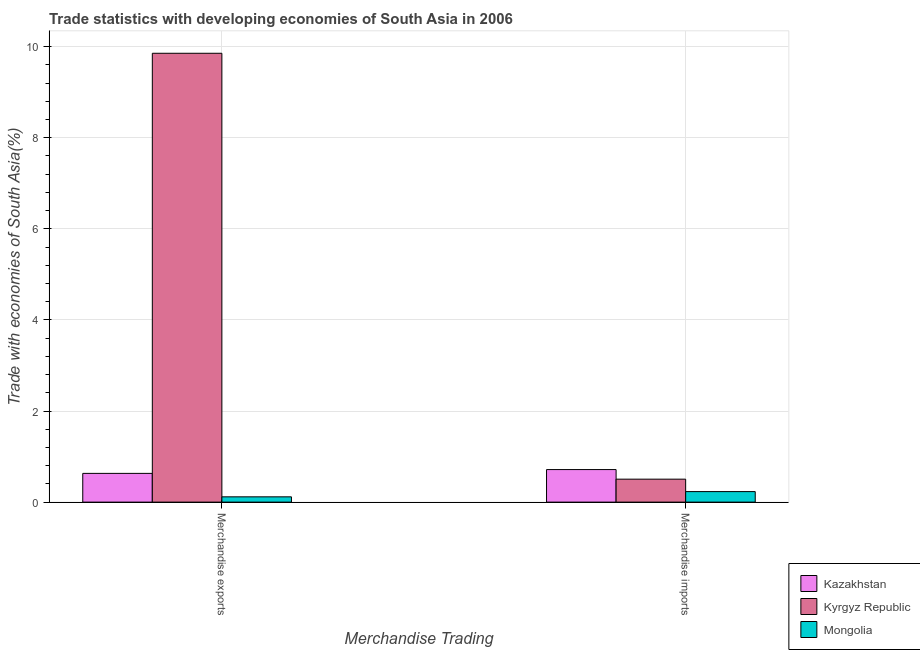How many different coloured bars are there?
Offer a terse response. 3. How many groups of bars are there?
Ensure brevity in your answer.  2. Are the number of bars on each tick of the X-axis equal?
Offer a terse response. Yes. How many bars are there on the 1st tick from the left?
Your response must be concise. 3. How many bars are there on the 1st tick from the right?
Offer a terse response. 3. What is the merchandise exports in Kyrgyz Republic?
Give a very brief answer. 9.85. Across all countries, what is the maximum merchandise exports?
Provide a short and direct response. 9.85. Across all countries, what is the minimum merchandise exports?
Provide a short and direct response. 0.12. In which country was the merchandise imports maximum?
Keep it short and to the point. Kazakhstan. In which country was the merchandise exports minimum?
Keep it short and to the point. Mongolia. What is the total merchandise imports in the graph?
Give a very brief answer. 1.45. What is the difference between the merchandise exports in Kyrgyz Republic and that in Kazakhstan?
Your answer should be compact. 9.22. What is the difference between the merchandise exports in Kazakhstan and the merchandise imports in Mongolia?
Provide a short and direct response. 0.4. What is the average merchandise exports per country?
Offer a very short reply. 3.53. What is the difference between the merchandise exports and merchandise imports in Kazakhstan?
Offer a terse response. -0.08. In how many countries, is the merchandise imports greater than 2.8 %?
Keep it short and to the point. 0. What is the ratio of the merchandise exports in Mongolia to that in Kyrgyz Republic?
Provide a short and direct response. 0.01. In how many countries, is the merchandise imports greater than the average merchandise imports taken over all countries?
Give a very brief answer. 2. What does the 2nd bar from the left in Merchandise imports represents?
Keep it short and to the point. Kyrgyz Republic. What does the 1st bar from the right in Merchandise exports represents?
Your answer should be compact. Mongolia. What is the difference between two consecutive major ticks on the Y-axis?
Offer a very short reply. 2. Are the values on the major ticks of Y-axis written in scientific E-notation?
Your answer should be compact. No. Does the graph contain any zero values?
Offer a terse response. No. Does the graph contain grids?
Provide a succinct answer. Yes. How many legend labels are there?
Provide a succinct answer. 3. How are the legend labels stacked?
Provide a succinct answer. Vertical. What is the title of the graph?
Offer a very short reply. Trade statistics with developing economies of South Asia in 2006. Does "Bangladesh" appear as one of the legend labels in the graph?
Provide a succinct answer. No. What is the label or title of the X-axis?
Keep it short and to the point. Merchandise Trading. What is the label or title of the Y-axis?
Offer a very short reply. Trade with economies of South Asia(%). What is the Trade with economies of South Asia(%) in Kazakhstan in Merchandise exports?
Offer a very short reply. 0.63. What is the Trade with economies of South Asia(%) in Kyrgyz Republic in Merchandise exports?
Make the answer very short. 9.85. What is the Trade with economies of South Asia(%) of Mongolia in Merchandise exports?
Make the answer very short. 0.12. What is the Trade with economies of South Asia(%) of Kazakhstan in Merchandise imports?
Keep it short and to the point. 0.71. What is the Trade with economies of South Asia(%) of Kyrgyz Republic in Merchandise imports?
Offer a very short reply. 0.5. What is the Trade with economies of South Asia(%) in Mongolia in Merchandise imports?
Give a very brief answer. 0.23. Across all Merchandise Trading, what is the maximum Trade with economies of South Asia(%) in Kazakhstan?
Make the answer very short. 0.71. Across all Merchandise Trading, what is the maximum Trade with economies of South Asia(%) in Kyrgyz Republic?
Your answer should be very brief. 9.85. Across all Merchandise Trading, what is the maximum Trade with economies of South Asia(%) of Mongolia?
Provide a succinct answer. 0.23. Across all Merchandise Trading, what is the minimum Trade with economies of South Asia(%) in Kazakhstan?
Keep it short and to the point. 0.63. Across all Merchandise Trading, what is the minimum Trade with economies of South Asia(%) in Kyrgyz Republic?
Your response must be concise. 0.5. Across all Merchandise Trading, what is the minimum Trade with economies of South Asia(%) of Mongolia?
Provide a succinct answer. 0.12. What is the total Trade with economies of South Asia(%) in Kazakhstan in the graph?
Give a very brief answer. 1.35. What is the total Trade with economies of South Asia(%) of Kyrgyz Republic in the graph?
Your response must be concise. 10.36. What is the total Trade with economies of South Asia(%) of Mongolia in the graph?
Ensure brevity in your answer.  0.35. What is the difference between the Trade with economies of South Asia(%) in Kazakhstan in Merchandise exports and that in Merchandise imports?
Your answer should be compact. -0.08. What is the difference between the Trade with economies of South Asia(%) of Kyrgyz Republic in Merchandise exports and that in Merchandise imports?
Your response must be concise. 9.35. What is the difference between the Trade with economies of South Asia(%) of Mongolia in Merchandise exports and that in Merchandise imports?
Offer a terse response. -0.11. What is the difference between the Trade with economies of South Asia(%) of Kazakhstan in Merchandise exports and the Trade with economies of South Asia(%) of Kyrgyz Republic in Merchandise imports?
Offer a terse response. 0.13. What is the difference between the Trade with economies of South Asia(%) of Kazakhstan in Merchandise exports and the Trade with economies of South Asia(%) of Mongolia in Merchandise imports?
Provide a short and direct response. 0.4. What is the difference between the Trade with economies of South Asia(%) in Kyrgyz Republic in Merchandise exports and the Trade with economies of South Asia(%) in Mongolia in Merchandise imports?
Your answer should be very brief. 9.62. What is the average Trade with economies of South Asia(%) in Kazakhstan per Merchandise Trading?
Your answer should be very brief. 0.67. What is the average Trade with economies of South Asia(%) of Kyrgyz Republic per Merchandise Trading?
Make the answer very short. 5.18. What is the average Trade with economies of South Asia(%) of Mongolia per Merchandise Trading?
Your answer should be compact. 0.17. What is the difference between the Trade with economies of South Asia(%) in Kazakhstan and Trade with economies of South Asia(%) in Kyrgyz Republic in Merchandise exports?
Your answer should be very brief. -9.22. What is the difference between the Trade with economies of South Asia(%) of Kazakhstan and Trade with economies of South Asia(%) of Mongolia in Merchandise exports?
Keep it short and to the point. 0.51. What is the difference between the Trade with economies of South Asia(%) of Kyrgyz Republic and Trade with economies of South Asia(%) of Mongolia in Merchandise exports?
Your answer should be compact. 9.74. What is the difference between the Trade with economies of South Asia(%) in Kazakhstan and Trade with economies of South Asia(%) in Kyrgyz Republic in Merchandise imports?
Make the answer very short. 0.21. What is the difference between the Trade with economies of South Asia(%) in Kazakhstan and Trade with economies of South Asia(%) in Mongolia in Merchandise imports?
Your answer should be very brief. 0.48. What is the difference between the Trade with economies of South Asia(%) in Kyrgyz Republic and Trade with economies of South Asia(%) in Mongolia in Merchandise imports?
Offer a terse response. 0.27. What is the ratio of the Trade with economies of South Asia(%) in Kazakhstan in Merchandise exports to that in Merchandise imports?
Your answer should be very brief. 0.88. What is the ratio of the Trade with economies of South Asia(%) of Kyrgyz Republic in Merchandise exports to that in Merchandise imports?
Provide a succinct answer. 19.55. What is the ratio of the Trade with economies of South Asia(%) of Mongolia in Merchandise exports to that in Merchandise imports?
Offer a terse response. 0.5. What is the difference between the highest and the second highest Trade with economies of South Asia(%) in Kazakhstan?
Provide a short and direct response. 0.08. What is the difference between the highest and the second highest Trade with economies of South Asia(%) in Kyrgyz Republic?
Your answer should be compact. 9.35. What is the difference between the highest and the second highest Trade with economies of South Asia(%) of Mongolia?
Keep it short and to the point. 0.11. What is the difference between the highest and the lowest Trade with economies of South Asia(%) of Kazakhstan?
Ensure brevity in your answer.  0.08. What is the difference between the highest and the lowest Trade with economies of South Asia(%) in Kyrgyz Republic?
Your answer should be compact. 9.35. What is the difference between the highest and the lowest Trade with economies of South Asia(%) of Mongolia?
Keep it short and to the point. 0.11. 